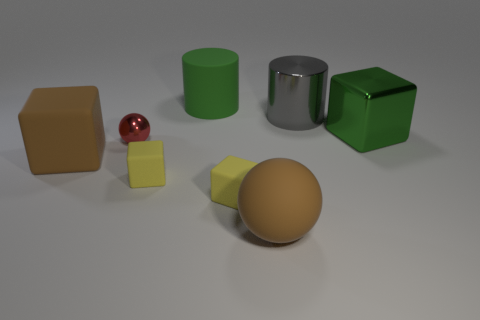Subtract 1 cubes. How many cubes are left? 3 Add 2 brown matte things. How many objects exist? 10 Subtract all balls. How many objects are left? 6 Subtract all red spheres. Subtract all small green rubber blocks. How many objects are left? 7 Add 8 small red spheres. How many small red spheres are left? 9 Add 3 big red metallic blocks. How many big red metallic blocks exist? 3 Subtract 0 blue cylinders. How many objects are left? 8 